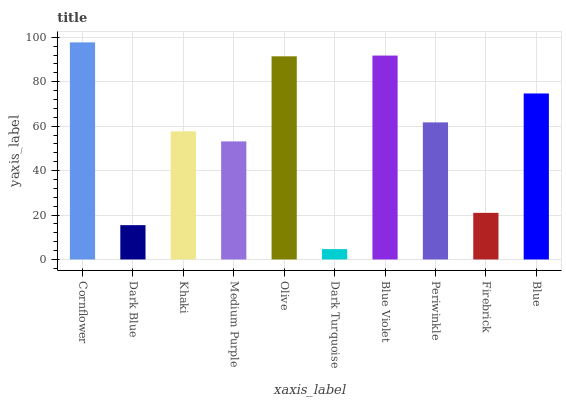Is Dark Turquoise the minimum?
Answer yes or no. Yes. Is Cornflower the maximum?
Answer yes or no. Yes. Is Dark Blue the minimum?
Answer yes or no. No. Is Dark Blue the maximum?
Answer yes or no. No. Is Cornflower greater than Dark Blue?
Answer yes or no. Yes. Is Dark Blue less than Cornflower?
Answer yes or no. Yes. Is Dark Blue greater than Cornflower?
Answer yes or no. No. Is Cornflower less than Dark Blue?
Answer yes or no. No. Is Periwinkle the high median?
Answer yes or no. Yes. Is Khaki the low median?
Answer yes or no. Yes. Is Dark Turquoise the high median?
Answer yes or no. No. Is Blue the low median?
Answer yes or no. No. 